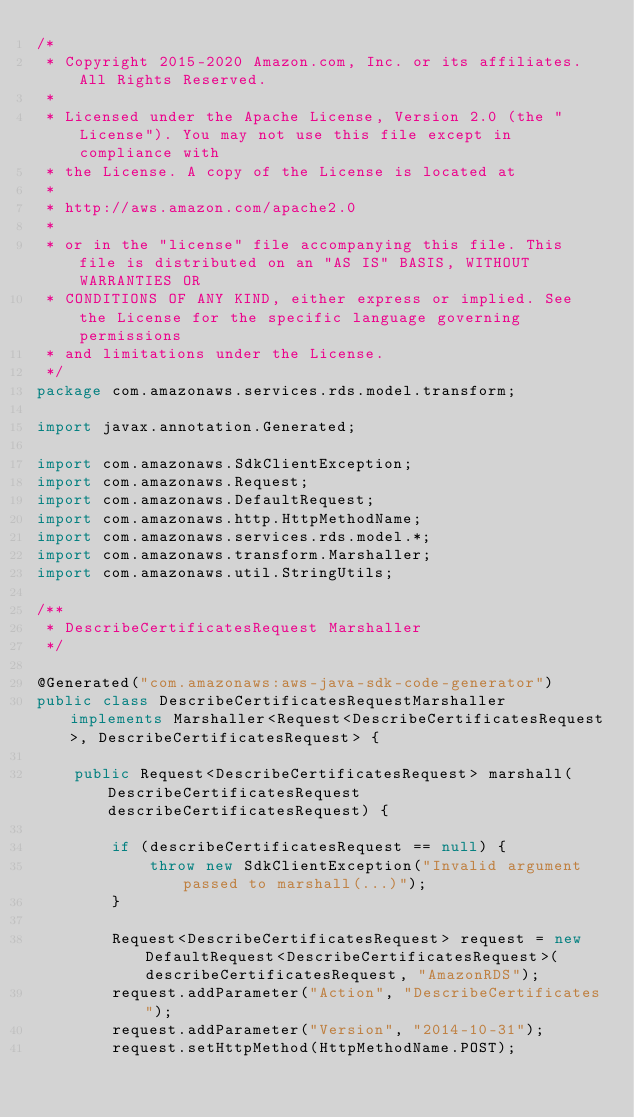<code> <loc_0><loc_0><loc_500><loc_500><_Java_>/*
 * Copyright 2015-2020 Amazon.com, Inc. or its affiliates. All Rights Reserved.
 * 
 * Licensed under the Apache License, Version 2.0 (the "License"). You may not use this file except in compliance with
 * the License. A copy of the License is located at
 * 
 * http://aws.amazon.com/apache2.0
 * 
 * or in the "license" file accompanying this file. This file is distributed on an "AS IS" BASIS, WITHOUT WARRANTIES OR
 * CONDITIONS OF ANY KIND, either express or implied. See the License for the specific language governing permissions
 * and limitations under the License.
 */
package com.amazonaws.services.rds.model.transform;

import javax.annotation.Generated;

import com.amazonaws.SdkClientException;
import com.amazonaws.Request;
import com.amazonaws.DefaultRequest;
import com.amazonaws.http.HttpMethodName;
import com.amazonaws.services.rds.model.*;
import com.amazonaws.transform.Marshaller;
import com.amazonaws.util.StringUtils;

/**
 * DescribeCertificatesRequest Marshaller
 */

@Generated("com.amazonaws:aws-java-sdk-code-generator")
public class DescribeCertificatesRequestMarshaller implements Marshaller<Request<DescribeCertificatesRequest>, DescribeCertificatesRequest> {

    public Request<DescribeCertificatesRequest> marshall(DescribeCertificatesRequest describeCertificatesRequest) {

        if (describeCertificatesRequest == null) {
            throw new SdkClientException("Invalid argument passed to marshall(...)");
        }

        Request<DescribeCertificatesRequest> request = new DefaultRequest<DescribeCertificatesRequest>(describeCertificatesRequest, "AmazonRDS");
        request.addParameter("Action", "DescribeCertificates");
        request.addParameter("Version", "2014-10-31");
        request.setHttpMethod(HttpMethodName.POST);
</code> 